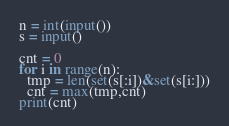<code> <loc_0><loc_0><loc_500><loc_500><_Python_>n = int(input())
s = input()

cnt = 0
for i in range(n):
  tmp = len(set(s[:i])&set(s[i:]))
  cnt = max(tmp,cnt)
print(cnt)</code> 